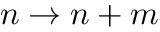<formula> <loc_0><loc_0><loc_500><loc_500>n \rightarrow n + m</formula> 